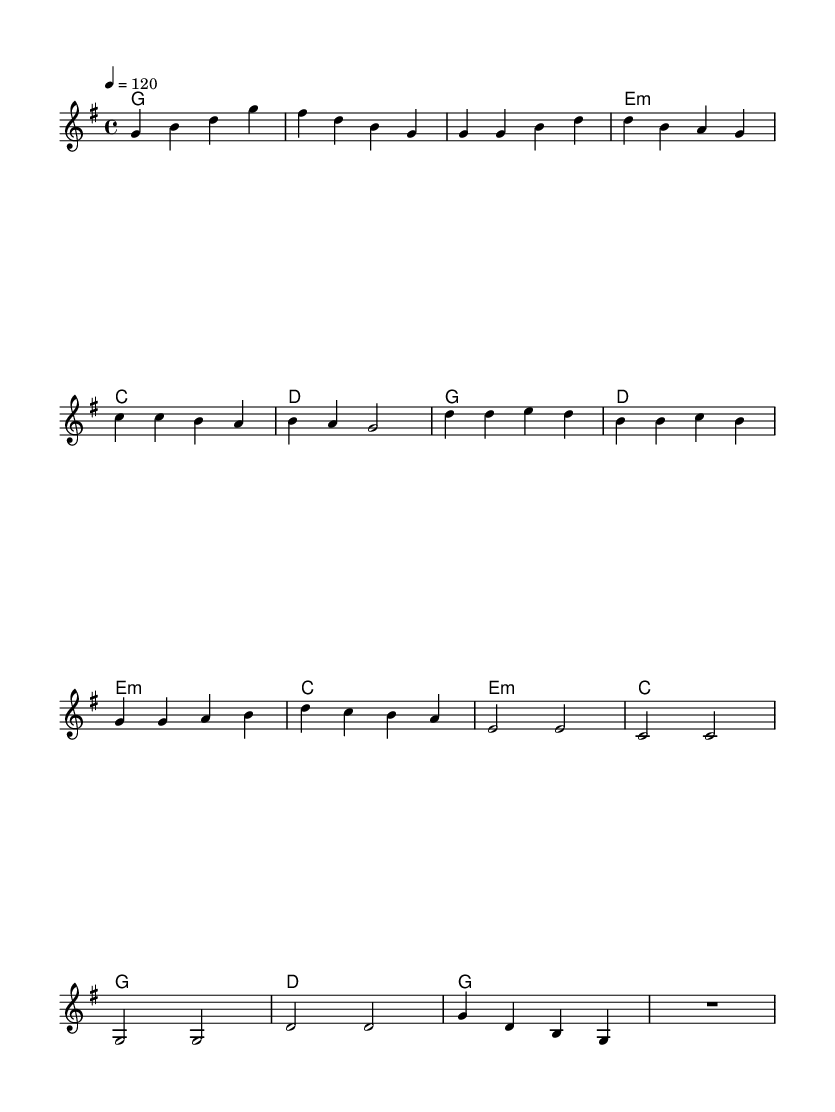What is the key signature of this music? The key signature is G major, indicated by one sharp (F#) in the context of the staff.
Answer: G major What is the time signature of this music? The time signature is 4/4, shown at the beginning of the score as a fraction with a four on top and bottom, indicating four beats per measure.
Answer: 4/4 What is the tempo marking for this piece? The tempo marking is 120 beats per minute, noted in the score saying "4 = 120," which directs the pace of the music.
Answer: 120 How many measures are in the chorus section? The chorus consists of four measures, as counted from the melody where it repeats distinct musical phrases within that section.
Answer: 4 Which chord is used in the bridge section? The bridge features an E minor chord, identified in the harmonies; this chord is indicated in the chord symbols beneath the staff.
Answer: E minor What type of musical structure is prominent in this dance? The structure is based on the verse-chorus-bridge formats, popular in dance music; this can be seen in the organization of the sections within the score.
Answer: Verse-chorus-bridge What traditional themes does the music reflect? The music reflects themes of traditional farming practices, emphasized by its electronic folk fusion style, which is integral to the dance composition.
Answer: Traditional farming practices 